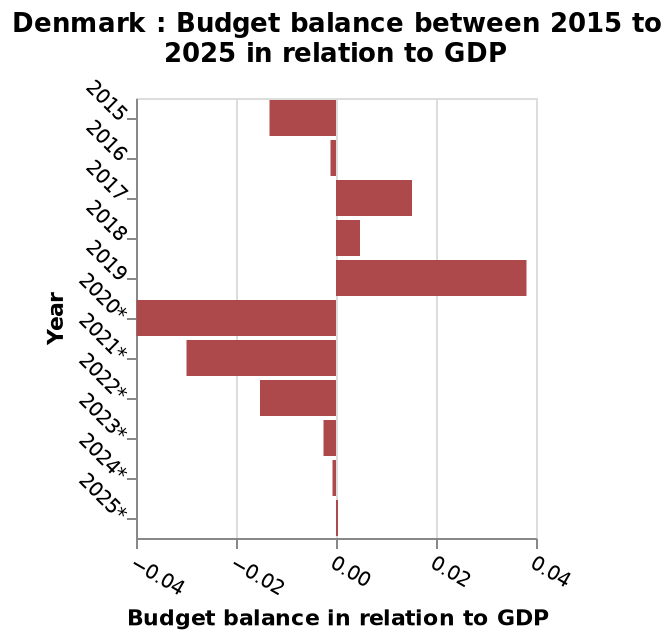<image>
please describe the details of the chart Denmark : Budget balance between 2015 to 2025 in relation to GDP is a bar diagram. A categorical scale from −0.04 to 0.04 can be found on the x-axis, marked Budget balance in relation to GDP. A categorical scale with 2015 on one end and 2025* at the other can be seen on the y-axis, marked Year. Can we determine any relationship between the years given?  No, it is uncertain whether any relationship exists between the years provided. What is the scale on the y-axis in the bar diagram?  The scale on the y-axis is a categorical scale ranging from 2015 to 2025*, marked as Year. What is the range of the categorical scale on the x-axis? The range of the categorical scale on the x-axis is from −0.04 to 0.04. Offer a thorough analysis of the image. There is no correlation with the years, it is uncertain. 